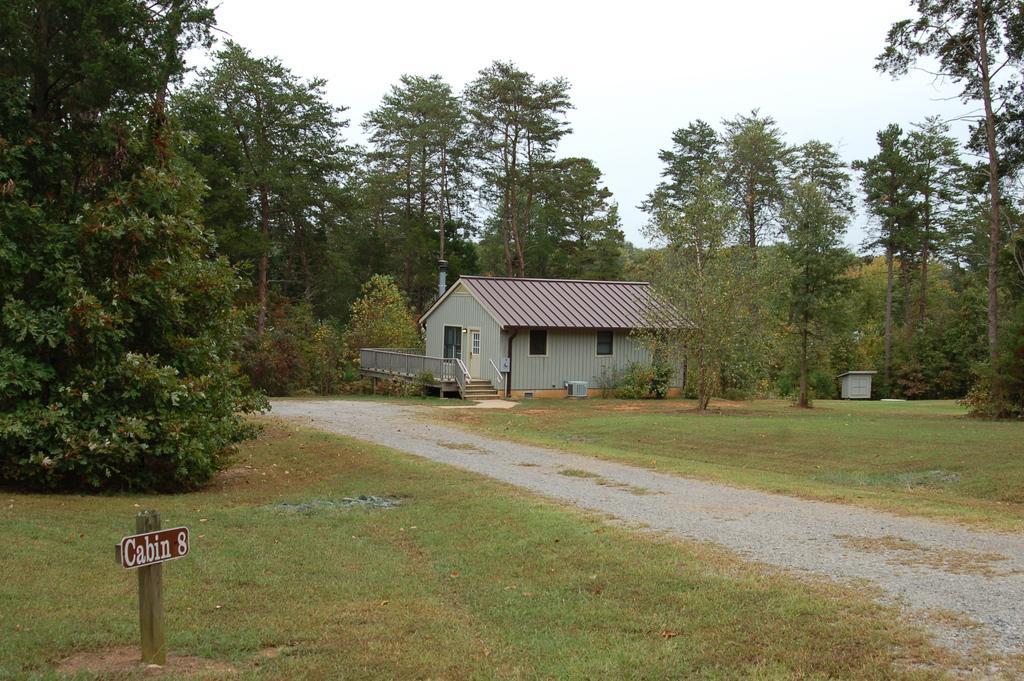In one or two sentences, can you explain what this image depicts? In this image there is a house having staircase. There are plants and trees on the grassland. Right side there is a path. Left bottom there is a board attached to the pole. There is some text on the board. Top of the image there is sky. 